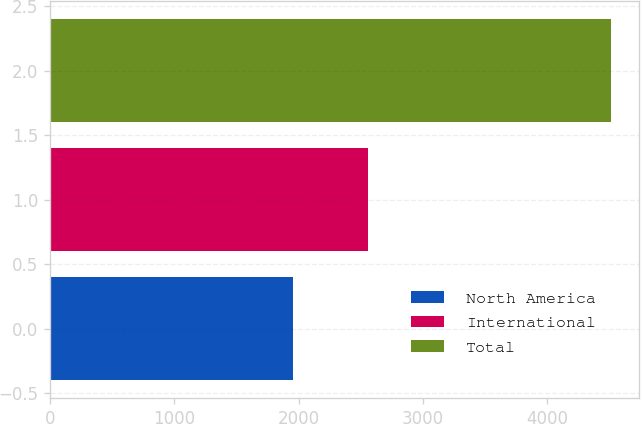<chart> <loc_0><loc_0><loc_500><loc_500><bar_chart><fcel>North America<fcel>International<fcel>Total<nl><fcel>1956<fcel>2559<fcel>4515<nl></chart> 